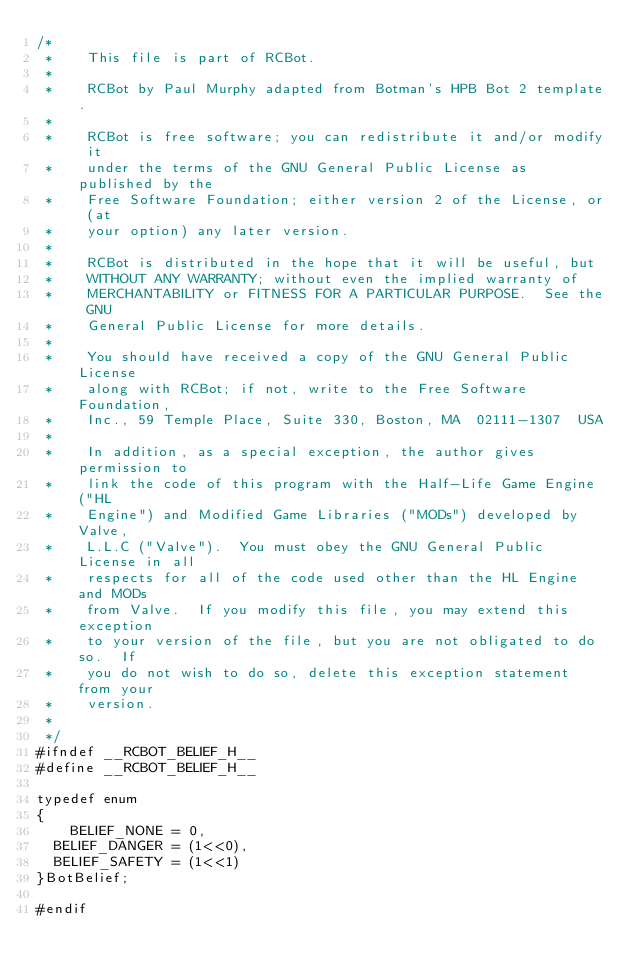Convert code to text. <code><loc_0><loc_0><loc_500><loc_500><_C_>/*
 *    This file is part of RCBot.
 *
 *    RCBot by Paul Murphy adapted from Botman's HPB Bot 2 template.
 *
 *    RCBot is free software; you can redistribute it and/or modify it
 *    under the terms of the GNU General Public License as published by the
 *    Free Software Foundation; either version 2 of the License, or (at
 *    your option) any later version.
 *
 *    RCBot is distributed in the hope that it will be useful, but
 *    WITHOUT ANY WARRANTY; without even the implied warranty of
 *    MERCHANTABILITY or FITNESS FOR A PARTICULAR PURPOSE.  See the GNU
 *    General Public License for more details.
 *
 *    You should have received a copy of the GNU General Public License
 *    along with RCBot; if not, write to the Free Software Foundation,
 *    Inc., 59 Temple Place, Suite 330, Boston, MA  02111-1307  USA
 *
 *    In addition, as a special exception, the author gives permission to
 *    link the code of this program with the Half-Life Game Engine ("HL
 *    Engine") and Modified Game Libraries ("MODs") developed by Valve,
 *    L.L.C ("Valve").  You must obey the GNU General Public License in all
 *    respects for all of the code used other than the HL Engine and MODs
 *    from Valve.  If you modify this file, you may extend this exception
 *    to your version of the file, but you are not obligated to do so.  If
 *    you do not wish to do so, delete this exception statement from your
 *    version.
 *
 */
#ifndef __RCBOT_BELIEF_H__
#define __RCBOT_BELIEF_H__

typedef enum
{
    BELIEF_NONE = 0,
	BELIEF_DANGER = (1<<0),
	BELIEF_SAFETY = (1<<1)
}BotBelief;

#endif</code> 